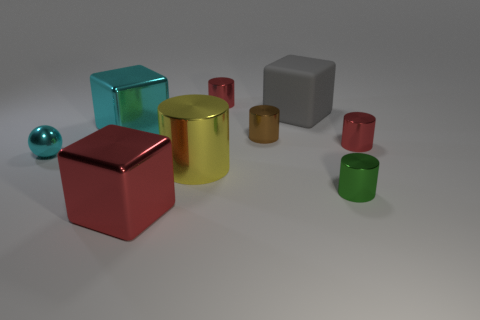How many things are either big metallic cubes or tiny green shiny things?
Your response must be concise. 3. How many other objects are there of the same size as the rubber thing?
Offer a terse response. 3. How many large cubes are behind the green cylinder and to the left of the large yellow metallic cylinder?
Provide a succinct answer. 1. Is the size of the green metallic cylinder that is to the right of the matte thing the same as the cyan shiny thing on the left side of the large cyan metallic block?
Ensure brevity in your answer.  Yes. There is a red metal thing behind the big gray cube; how big is it?
Make the answer very short. Small. How many things are either tiny metallic cylinders that are in front of the large cyan metal cube or large metallic objects that are in front of the green cylinder?
Your answer should be very brief. 4. Is there any other thing of the same color as the big cylinder?
Offer a terse response. No. Are there the same number of metallic blocks behind the big gray rubber cube and small cyan objects that are in front of the tiny green shiny cylinder?
Your answer should be compact. Yes. Are there more big cyan metallic cubes that are in front of the tiny cyan metal thing than brown shiny objects?
Your answer should be very brief. No. What number of things are either tiny red things in front of the large matte cube or big gray rubber blocks?
Offer a terse response. 2. 